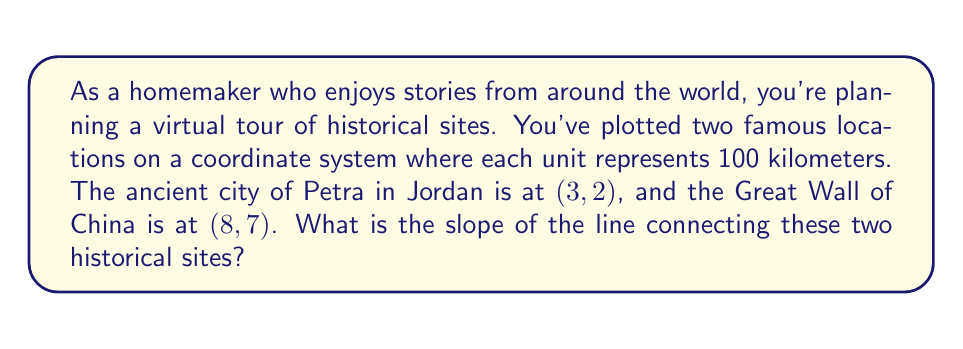Could you help me with this problem? To find the slope of the line connecting two points, we use the slope formula:

$$ \text{slope} = m = \frac{y_2 - y_1}{x_2 - x_1} $$

Where $(x_1, y_1)$ is the first point and $(x_2, y_2)$ is the second point.

Let's assign our points:
- Petra: $(x_1, y_1) = (3, 2)$
- Great Wall of China: $(x_2, y_2) = (8, 7)$

Now, let's plug these values into our slope formula:

$$ m = \frac{7 - 2}{8 - 3} = \frac{5}{5} = 1 $$

The slope of 1 means that for every 1 unit we move to the right (100 km east), we also move 1 unit up (100 km north) as we travel from Petra to the Great Wall of China.

[asy]
unitsize(1cm);
defaultpen(fontsize(10pt));

// Draw axes
draw((-1,0)--(9,0), arrow=Arrow(TeXHead));
draw((0,-1)--(0,8), arrow=Arrow(TeXHead));

// Label axes
label("x", (9,0), E);
label("y", (0,8), N);

// Plot points
dot((3,2));
dot((8,7));

// Draw line
draw((3,2)--(8,7), blue);

// Label points
label("Petra (3, 2)", (3,2), SW);
label("Great Wall (8, 7)", (8,7), NE);

// Add grid
for(int i=-1; i<=9; ++i) {
  draw((i,-0.1)--(i,0.1));
  if(i>0 && i<9) label(string(i), (i,0), S);
}
for(int j=-1; j<=8; ++j) {
  draw((-0.1,j)--(0.1,j));
  if(j>0 && j<8) label(string(j), (0,j), W);
}
[/asy]
Answer: $1$ 